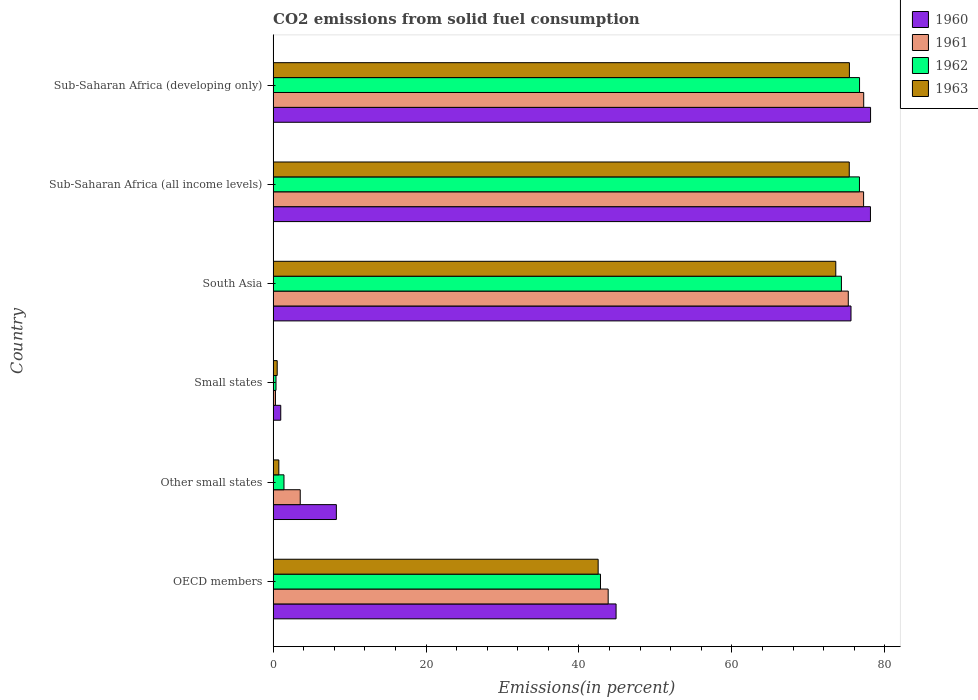How many different coloured bars are there?
Your answer should be very brief. 4. How many groups of bars are there?
Ensure brevity in your answer.  6. What is the label of the 2nd group of bars from the top?
Ensure brevity in your answer.  Sub-Saharan Africa (all income levels). In how many cases, is the number of bars for a given country not equal to the number of legend labels?
Offer a very short reply. 0. What is the total CO2 emitted in 1960 in Other small states?
Keep it short and to the point. 8.27. Across all countries, what is the maximum total CO2 emitted in 1963?
Provide a short and direct response. 75.37. Across all countries, what is the minimum total CO2 emitted in 1962?
Your answer should be compact. 0.38. In which country was the total CO2 emitted in 1962 maximum?
Your response must be concise. Sub-Saharan Africa (developing only). In which country was the total CO2 emitted in 1962 minimum?
Provide a short and direct response. Small states. What is the total total CO2 emitted in 1961 in the graph?
Make the answer very short. 277.38. What is the difference between the total CO2 emitted in 1960 in South Asia and that in Sub-Saharan Africa (all income levels)?
Offer a very short reply. -2.54. What is the difference between the total CO2 emitted in 1960 in Sub-Saharan Africa (all income levels) and the total CO2 emitted in 1961 in South Asia?
Keep it short and to the point. 2.9. What is the average total CO2 emitted in 1961 per country?
Ensure brevity in your answer.  46.23. What is the difference between the total CO2 emitted in 1961 and total CO2 emitted in 1962 in South Asia?
Ensure brevity in your answer.  0.9. What is the ratio of the total CO2 emitted in 1961 in Other small states to that in Sub-Saharan Africa (all income levels)?
Give a very brief answer. 0.05. Is the total CO2 emitted in 1963 in Small states less than that in Sub-Saharan Africa (developing only)?
Your answer should be compact. Yes. What is the difference between the highest and the second highest total CO2 emitted in 1963?
Your answer should be very brief. 0.02. What is the difference between the highest and the lowest total CO2 emitted in 1961?
Give a very brief answer. 76.94. In how many countries, is the total CO2 emitted in 1961 greater than the average total CO2 emitted in 1961 taken over all countries?
Your response must be concise. 3. Is the sum of the total CO2 emitted in 1963 in Other small states and Small states greater than the maximum total CO2 emitted in 1960 across all countries?
Your response must be concise. No. Is it the case that in every country, the sum of the total CO2 emitted in 1963 and total CO2 emitted in 1961 is greater than the sum of total CO2 emitted in 1960 and total CO2 emitted in 1962?
Ensure brevity in your answer.  No. Is it the case that in every country, the sum of the total CO2 emitted in 1960 and total CO2 emitted in 1963 is greater than the total CO2 emitted in 1961?
Keep it short and to the point. Yes. How many bars are there?
Give a very brief answer. 24. How many countries are there in the graph?
Your response must be concise. 6. What is the difference between two consecutive major ticks on the X-axis?
Offer a terse response. 20. Are the values on the major ticks of X-axis written in scientific E-notation?
Your answer should be very brief. No. Does the graph contain any zero values?
Your answer should be very brief. No. Where does the legend appear in the graph?
Provide a succinct answer. Top right. How many legend labels are there?
Your answer should be very brief. 4. How are the legend labels stacked?
Provide a short and direct response. Vertical. What is the title of the graph?
Offer a terse response. CO2 emissions from solid fuel consumption. What is the label or title of the X-axis?
Offer a very short reply. Emissions(in percent). What is the Emissions(in percent) in 1960 in OECD members?
Provide a short and direct response. 44.86. What is the Emissions(in percent) in 1961 in OECD members?
Your answer should be compact. 43.82. What is the Emissions(in percent) of 1962 in OECD members?
Provide a succinct answer. 42.82. What is the Emissions(in percent) of 1963 in OECD members?
Give a very brief answer. 42.51. What is the Emissions(in percent) in 1960 in Other small states?
Your response must be concise. 8.27. What is the Emissions(in percent) in 1961 in Other small states?
Make the answer very short. 3.55. What is the Emissions(in percent) in 1962 in Other small states?
Ensure brevity in your answer.  1.42. What is the Emissions(in percent) in 1963 in Other small states?
Provide a succinct answer. 0.75. What is the Emissions(in percent) of 1960 in Small states?
Give a very brief answer. 1. What is the Emissions(in percent) of 1961 in Small states?
Provide a succinct answer. 0.31. What is the Emissions(in percent) in 1962 in Small states?
Give a very brief answer. 0.38. What is the Emissions(in percent) in 1963 in Small states?
Give a very brief answer. 0.53. What is the Emissions(in percent) of 1960 in South Asia?
Give a very brief answer. 75.58. What is the Emissions(in percent) in 1961 in South Asia?
Your response must be concise. 75.23. What is the Emissions(in percent) in 1962 in South Asia?
Offer a terse response. 74.33. What is the Emissions(in percent) in 1963 in South Asia?
Keep it short and to the point. 73.59. What is the Emissions(in percent) of 1960 in Sub-Saharan Africa (all income levels)?
Your answer should be compact. 78.13. What is the Emissions(in percent) in 1961 in Sub-Saharan Africa (all income levels)?
Offer a terse response. 77.23. What is the Emissions(in percent) of 1962 in Sub-Saharan Africa (all income levels)?
Provide a short and direct response. 76.69. What is the Emissions(in percent) in 1963 in Sub-Saharan Africa (all income levels)?
Ensure brevity in your answer.  75.35. What is the Emissions(in percent) of 1960 in Sub-Saharan Africa (developing only)?
Your answer should be compact. 78.14. What is the Emissions(in percent) of 1961 in Sub-Saharan Africa (developing only)?
Your response must be concise. 77.24. What is the Emissions(in percent) of 1962 in Sub-Saharan Africa (developing only)?
Your response must be concise. 76.7. What is the Emissions(in percent) in 1963 in Sub-Saharan Africa (developing only)?
Provide a short and direct response. 75.37. Across all countries, what is the maximum Emissions(in percent) in 1960?
Offer a terse response. 78.14. Across all countries, what is the maximum Emissions(in percent) of 1961?
Make the answer very short. 77.24. Across all countries, what is the maximum Emissions(in percent) of 1962?
Keep it short and to the point. 76.7. Across all countries, what is the maximum Emissions(in percent) in 1963?
Give a very brief answer. 75.37. Across all countries, what is the minimum Emissions(in percent) in 1960?
Your answer should be compact. 1. Across all countries, what is the minimum Emissions(in percent) in 1961?
Offer a terse response. 0.31. Across all countries, what is the minimum Emissions(in percent) of 1962?
Offer a terse response. 0.38. Across all countries, what is the minimum Emissions(in percent) in 1963?
Provide a succinct answer. 0.53. What is the total Emissions(in percent) in 1960 in the graph?
Make the answer very short. 285.97. What is the total Emissions(in percent) in 1961 in the graph?
Offer a very short reply. 277.38. What is the total Emissions(in percent) of 1962 in the graph?
Give a very brief answer. 272.33. What is the total Emissions(in percent) in 1963 in the graph?
Offer a very short reply. 268.11. What is the difference between the Emissions(in percent) in 1960 in OECD members and that in Other small states?
Ensure brevity in your answer.  36.58. What is the difference between the Emissions(in percent) of 1961 in OECD members and that in Other small states?
Your answer should be compact. 40.28. What is the difference between the Emissions(in percent) in 1962 in OECD members and that in Other small states?
Your answer should be very brief. 41.4. What is the difference between the Emissions(in percent) of 1963 in OECD members and that in Other small states?
Make the answer very short. 41.77. What is the difference between the Emissions(in percent) in 1960 in OECD members and that in Small states?
Your answer should be very brief. 43.86. What is the difference between the Emissions(in percent) in 1961 in OECD members and that in Small states?
Offer a terse response. 43.52. What is the difference between the Emissions(in percent) in 1962 in OECD members and that in Small states?
Offer a very short reply. 42.44. What is the difference between the Emissions(in percent) in 1963 in OECD members and that in Small states?
Offer a very short reply. 41.98. What is the difference between the Emissions(in percent) in 1960 in OECD members and that in South Asia?
Offer a very short reply. -30.73. What is the difference between the Emissions(in percent) of 1961 in OECD members and that in South Asia?
Offer a very short reply. -31.41. What is the difference between the Emissions(in percent) in 1962 in OECD members and that in South Asia?
Keep it short and to the point. -31.51. What is the difference between the Emissions(in percent) of 1963 in OECD members and that in South Asia?
Offer a terse response. -31.08. What is the difference between the Emissions(in percent) in 1960 in OECD members and that in Sub-Saharan Africa (all income levels)?
Ensure brevity in your answer.  -33.27. What is the difference between the Emissions(in percent) of 1961 in OECD members and that in Sub-Saharan Africa (all income levels)?
Your response must be concise. -33.41. What is the difference between the Emissions(in percent) of 1962 in OECD members and that in Sub-Saharan Africa (all income levels)?
Offer a very short reply. -33.87. What is the difference between the Emissions(in percent) in 1963 in OECD members and that in Sub-Saharan Africa (all income levels)?
Offer a terse response. -32.84. What is the difference between the Emissions(in percent) in 1960 in OECD members and that in Sub-Saharan Africa (developing only)?
Ensure brevity in your answer.  -33.28. What is the difference between the Emissions(in percent) in 1961 in OECD members and that in Sub-Saharan Africa (developing only)?
Your answer should be compact. -33.42. What is the difference between the Emissions(in percent) in 1962 in OECD members and that in Sub-Saharan Africa (developing only)?
Ensure brevity in your answer.  -33.89. What is the difference between the Emissions(in percent) in 1963 in OECD members and that in Sub-Saharan Africa (developing only)?
Your answer should be compact. -32.86. What is the difference between the Emissions(in percent) in 1960 in Other small states and that in Small states?
Keep it short and to the point. 7.27. What is the difference between the Emissions(in percent) of 1961 in Other small states and that in Small states?
Your answer should be very brief. 3.24. What is the difference between the Emissions(in percent) in 1962 in Other small states and that in Small states?
Provide a succinct answer. 1.04. What is the difference between the Emissions(in percent) in 1963 in Other small states and that in Small states?
Your response must be concise. 0.21. What is the difference between the Emissions(in percent) in 1960 in Other small states and that in South Asia?
Your response must be concise. -67.31. What is the difference between the Emissions(in percent) of 1961 in Other small states and that in South Asia?
Your answer should be very brief. -71.68. What is the difference between the Emissions(in percent) in 1962 in Other small states and that in South Asia?
Offer a terse response. -72.91. What is the difference between the Emissions(in percent) in 1963 in Other small states and that in South Asia?
Make the answer very short. -72.85. What is the difference between the Emissions(in percent) of 1960 in Other small states and that in Sub-Saharan Africa (all income levels)?
Your answer should be very brief. -69.86. What is the difference between the Emissions(in percent) of 1961 in Other small states and that in Sub-Saharan Africa (all income levels)?
Your answer should be compact. -73.68. What is the difference between the Emissions(in percent) of 1962 in Other small states and that in Sub-Saharan Africa (all income levels)?
Your response must be concise. -75.27. What is the difference between the Emissions(in percent) of 1963 in Other small states and that in Sub-Saharan Africa (all income levels)?
Offer a very short reply. -74.61. What is the difference between the Emissions(in percent) in 1960 in Other small states and that in Sub-Saharan Africa (developing only)?
Make the answer very short. -69.87. What is the difference between the Emissions(in percent) in 1961 in Other small states and that in Sub-Saharan Africa (developing only)?
Your answer should be compact. -73.7. What is the difference between the Emissions(in percent) of 1962 in Other small states and that in Sub-Saharan Africa (developing only)?
Keep it short and to the point. -75.28. What is the difference between the Emissions(in percent) of 1963 in Other small states and that in Sub-Saharan Africa (developing only)?
Your answer should be compact. -74.63. What is the difference between the Emissions(in percent) in 1960 in Small states and that in South Asia?
Make the answer very short. -74.58. What is the difference between the Emissions(in percent) in 1961 in Small states and that in South Asia?
Offer a terse response. -74.92. What is the difference between the Emissions(in percent) of 1962 in Small states and that in South Asia?
Provide a short and direct response. -73.95. What is the difference between the Emissions(in percent) of 1963 in Small states and that in South Asia?
Make the answer very short. -73.06. What is the difference between the Emissions(in percent) of 1960 in Small states and that in Sub-Saharan Africa (all income levels)?
Provide a short and direct response. -77.13. What is the difference between the Emissions(in percent) of 1961 in Small states and that in Sub-Saharan Africa (all income levels)?
Offer a terse response. -76.92. What is the difference between the Emissions(in percent) in 1962 in Small states and that in Sub-Saharan Africa (all income levels)?
Offer a very short reply. -76.31. What is the difference between the Emissions(in percent) in 1963 in Small states and that in Sub-Saharan Africa (all income levels)?
Your answer should be very brief. -74.82. What is the difference between the Emissions(in percent) of 1960 in Small states and that in Sub-Saharan Africa (developing only)?
Provide a succinct answer. -77.14. What is the difference between the Emissions(in percent) in 1961 in Small states and that in Sub-Saharan Africa (developing only)?
Your response must be concise. -76.94. What is the difference between the Emissions(in percent) of 1962 in Small states and that in Sub-Saharan Africa (developing only)?
Ensure brevity in your answer.  -76.32. What is the difference between the Emissions(in percent) in 1963 in Small states and that in Sub-Saharan Africa (developing only)?
Provide a short and direct response. -74.84. What is the difference between the Emissions(in percent) of 1960 in South Asia and that in Sub-Saharan Africa (all income levels)?
Your answer should be compact. -2.54. What is the difference between the Emissions(in percent) in 1961 in South Asia and that in Sub-Saharan Africa (all income levels)?
Your response must be concise. -2. What is the difference between the Emissions(in percent) of 1962 in South Asia and that in Sub-Saharan Africa (all income levels)?
Your response must be concise. -2.36. What is the difference between the Emissions(in percent) of 1963 in South Asia and that in Sub-Saharan Africa (all income levels)?
Provide a short and direct response. -1.76. What is the difference between the Emissions(in percent) in 1960 in South Asia and that in Sub-Saharan Africa (developing only)?
Ensure brevity in your answer.  -2.56. What is the difference between the Emissions(in percent) in 1961 in South Asia and that in Sub-Saharan Africa (developing only)?
Make the answer very short. -2.02. What is the difference between the Emissions(in percent) in 1962 in South Asia and that in Sub-Saharan Africa (developing only)?
Your answer should be compact. -2.37. What is the difference between the Emissions(in percent) of 1963 in South Asia and that in Sub-Saharan Africa (developing only)?
Provide a succinct answer. -1.78. What is the difference between the Emissions(in percent) in 1960 in Sub-Saharan Africa (all income levels) and that in Sub-Saharan Africa (developing only)?
Keep it short and to the point. -0.01. What is the difference between the Emissions(in percent) of 1961 in Sub-Saharan Africa (all income levels) and that in Sub-Saharan Africa (developing only)?
Provide a succinct answer. -0.01. What is the difference between the Emissions(in percent) of 1962 in Sub-Saharan Africa (all income levels) and that in Sub-Saharan Africa (developing only)?
Keep it short and to the point. -0.01. What is the difference between the Emissions(in percent) in 1963 in Sub-Saharan Africa (all income levels) and that in Sub-Saharan Africa (developing only)?
Provide a short and direct response. -0.02. What is the difference between the Emissions(in percent) in 1960 in OECD members and the Emissions(in percent) in 1961 in Other small states?
Keep it short and to the point. 41.31. What is the difference between the Emissions(in percent) in 1960 in OECD members and the Emissions(in percent) in 1962 in Other small states?
Your answer should be very brief. 43.44. What is the difference between the Emissions(in percent) of 1960 in OECD members and the Emissions(in percent) of 1963 in Other small states?
Your answer should be compact. 44.11. What is the difference between the Emissions(in percent) of 1961 in OECD members and the Emissions(in percent) of 1962 in Other small states?
Your answer should be compact. 42.4. What is the difference between the Emissions(in percent) in 1961 in OECD members and the Emissions(in percent) in 1963 in Other small states?
Your answer should be compact. 43.08. What is the difference between the Emissions(in percent) of 1962 in OECD members and the Emissions(in percent) of 1963 in Other small states?
Give a very brief answer. 42.07. What is the difference between the Emissions(in percent) in 1960 in OECD members and the Emissions(in percent) in 1961 in Small states?
Provide a short and direct response. 44.55. What is the difference between the Emissions(in percent) in 1960 in OECD members and the Emissions(in percent) in 1962 in Small states?
Offer a very short reply. 44.48. What is the difference between the Emissions(in percent) in 1960 in OECD members and the Emissions(in percent) in 1963 in Small states?
Give a very brief answer. 44.32. What is the difference between the Emissions(in percent) in 1961 in OECD members and the Emissions(in percent) in 1962 in Small states?
Ensure brevity in your answer.  43.45. What is the difference between the Emissions(in percent) of 1961 in OECD members and the Emissions(in percent) of 1963 in Small states?
Give a very brief answer. 43.29. What is the difference between the Emissions(in percent) of 1962 in OECD members and the Emissions(in percent) of 1963 in Small states?
Offer a terse response. 42.28. What is the difference between the Emissions(in percent) of 1960 in OECD members and the Emissions(in percent) of 1961 in South Asia?
Offer a very short reply. -30.37. What is the difference between the Emissions(in percent) of 1960 in OECD members and the Emissions(in percent) of 1962 in South Asia?
Provide a succinct answer. -29.47. What is the difference between the Emissions(in percent) in 1960 in OECD members and the Emissions(in percent) in 1963 in South Asia?
Your answer should be very brief. -28.74. What is the difference between the Emissions(in percent) of 1961 in OECD members and the Emissions(in percent) of 1962 in South Asia?
Provide a short and direct response. -30.51. What is the difference between the Emissions(in percent) in 1961 in OECD members and the Emissions(in percent) in 1963 in South Asia?
Keep it short and to the point. -29.77. What is the difference between the Emissions(in percent) in 1962 in OECD members and the Emissions(in percent) in 1963 in South Asia?
Keep it short and to the point. -30.78. What is the difference between the Emissions(in percent) in 1960 in OECD members and the Emissions(in percent) in 1961 in Sub-Saharan Africa (all income levels)?
Your response must be concise. -32.37. What is the difference between the Emissions(in percent) of 1960 in OECD members and the Emissions(in percent) of 1962 in Sub-Saharan Africa (all income levels)?
Keep it short and to the point. -31.83. What is the difference between the Emissions(in percent) of 1960 in OECD members and the Emissions(in percent) of 1963 in Sub-Saharan Africa (all income levels)?
Offer a terse response. -30.5. What is the difference between the Emissions(in percent) of 1961 in OECD members and the Emissions(in percent) of 1962 in Sub-Saharan Africa (all income levels)?
Provide a succinct answer. -32.87. What is the difference between the Emissions(in percent) of 1961 in OECD members and the Emissions(in percent) of 1963 in Sub-Saharan Africa (all income levels)?
Make the answer very short. -31.53. What is the difference between the Emissions(in percent) in 1962 in OECD members and the Emissions(in percent) in 1963 in Sub-Saharan Africa (all income levels)?
Provide a succinct answer. -32.54. What is the difference between the Emissions(in percent) in 1960 in OECD members and the Emissions(in percent) in 1961 in Sub-Saharan Africa (developing only)?
Offer a terse response. -32.39. What is the difference between the Emissions(in percent) of 1960 in OECD members and the Emissions(in percent) of 1962 in Sub-Saharan Africa (developing only)?
Ensure brevity in your answer.  -31.85. What is the difference between the Emissions(in percent) in 1960 in OECD members and the Emissions(in percent) in 1963 in Sub-Saharan Africa (developing only)?
Provide a short and direct response. -30.52. What is the difference between the Emissions(in percent) in 1961 in OECD members and the Emissions(in percent) in 1962 in Sub-Saharan Africa (developing only)?
Keep it short and to the point. -32.88. What is the difference between the Emissions(in percent) in 1961 in OECD members and the Emissions(in percent) in 1963 in Sub-Saharan Africa (developing only)?
Your answer should be compact. -31.55. What is the difference between the Emissions(in percent) of 1962 in OECD members and the Emissions(in percent) of 1963 in Sub-Saharan Africa (developing only)?
Keep it short and to the point. -32.56. What is the difference between the Emissions(in percent) of 1960 in Other small states and the Emissions(in percent) of 1961 in Small states?
Make the answer very short. 7.96. What is the difference between the Emissions(in percent) in 1960 in Other small states and the Emissions(in percent) in 1962 in Small states?
Make the answer very short. 7.89. What is the difference between the Emissions(in percent) in 1960 in Other small states and the Emissions(in percent) in 1963 in Small states?
Your answer should be compact. 7.74. What is the difference between the Emissions(in percent) of 1961 in Other small states and the Emissions(in percent) of 1962 in Small states?
Your response must be concise. 3.17. What is the difference between the Emissions(in percent) in 1961 in Other small states and the Emissions(in percent) in 1963 in Small states?
Provide a short and direct response. 3.01. What is the difference between the Emissions(in percent) of 1962 in Other small states and the Emissions(in percent) of 1963 in Small states?
Offer a very short reply. 0.88. What is the difference between the Emissions(in percent) in 1960 in Other small states and the Emissions(in percent) in 1961 in South Asia?
Offer a very short reply. -66.96. What is the difference between the Emissions(in percent) in 1960 in Other small states and the Emissions(in percent) in 1962 in South Asia?
Offer a very short reply. -66.06. What is the difference between the Emissions(in percent) of 1960 in Other small states and the Emissions(in percent) of 1963 in South Asia?
Your response must be concise. -65.32. What is the difference between the Emissions(in percent) in 1961 in Other small states and the Emissions(in percent) in 1962 in South Asia?
Offer a terse response. -70.78. What is the difference between the Emissions(in percent) of 1961 in Other small states and the Emissions(in percent) of 1963 in South Asia?
Provide a short and direct response. -70.05. What is the difference between the Emissions(in percent) of 1962 in Other small states and the Emissions(in percent) of 1963 in South Asia?
Offer a terse response. -72.17. What is the difference between the Emissions(in percent) of 1960 in Other small states and the Emissions(in percent) of 1961 in Sub-Saharan Africa (all income levels)?
Offer a very short reply. -68.96. What is the difference between the Emissions(in percent) in 1960 in Other small states and the Emissions(in percent) in 1962 in Sub-Saharan Africa (all income levels)?
Offer a terse response. -68.42. What is the difference between the Emissions(in percent) of 1960 in Other small states and the Emissions(in percent) of 1963 in Sub-Saharan Africa (all income levels)?
Provide a short and direct response. -67.08. What is the difference between the Emissions(in percent) in 1961 in Other small states and the Emissions(in percent) in 1962 in Sub-Saharan Africa (all income levels)?
Keep it short and to the point. -73.14. What is the difference between the Emissions(in percent) in 1961 in Other small states and the Emissions(in percent) in 1963 in Sub-Saharan Africa (all income levels)?
Provide a succinct answer. -71.81. What is the difference between the Emissions(in percent) of 1962 in Other small states and the Emissions(in percent) of 1963 in Sub-Saharan Africa (all income levels)?
Your answer should be very brief. -73.94. What is the difference between the Emissions(in percent) of 1960 in Other small states and the Emissions(in percent) of 1961 in Sub-Saharan Africa (developing only)?
Provide a short and direct response. -68.97. What is the difference between the Emissions(in percent) in 1960 in Other small states and the Emissions(in percent) in 1962 in Sub-Saharan Africa (developing only)?
Ensure brevity in your answer.  -68.43. What is the difference between the Emissions(in percent) in 1960 in Other small states and the Emissions(in percent) in 1963 in Sub-Saharan Africa (developing only)?
Provide a short and direct response. -67.1. What is the difference between the Emissions(in percent) in 1961 in Other small states and the Emissions(in percent) in 1962 in Sub-Saharan Africa (developing only)?
Your response must be concise. -73.15. What is the difference between the Emissions(in percent) of 1961 in Other small states and the Emissions(in percent) of 1963 in Sub-Saharan Africa (developing only)?
Provide a short and direct response. -71.83. What is the difference between the Emissions(in percent) of 1962 in Other small states and the Emissions(in percent) of 1963 in Sub-Saharan Africa (developing only)?
Your answer should be compact. -73.95. What is the difference between the Emissions(in percent) of 1960 in Small states and the Emissions(in percent) of 1961 in South Asia?
Provide a short and direct response. -74.23. What is the difference between the Emissions(in percent) of 1960 in Small states and the Emissions(in percent) of 1962 in South Asia?
Make the answer very short. -73.33. What is the difference between the Emissions(in percent) in 1960 in Small states and the Emissions(in percent) in 1963 in South Asia?
Make the answer very short. -72.59. What is the difference between the Emissions(in percent) of 1961 in Small states and the Emissions(in percent) of 1962 in South Asia?
Provide a short and direct response. -74.02. What is the difference between the Emissions(in percent) of 1961 in Small states and the Emissions(in percent) of 1963 in South Asia?
Provide a short and direct response. -73.29. What is the difference between the Emissions(in percent) in 1962 in Small states and the Emissions(in percent) in 1963 in South Asia?
Your answer should be compact. -73.22. What is the difference between the Emissions(in percent) in 1960 in Small states and the Emissions(in percent) in 1961 in Sub-Saharan Africa (all income levels)?
Your response must be concise. -76.23. What is the difference between the Emissions(in percent) in 1960 in Small states and the Emissions(in percent) in 1962 in Sub-Saharan Africa (all income levels)?
Provide a succinct answer. -75.69. What is the difference between the Emissions(in percent) of 1960 in Small states and the Emissions(in percent) of 1963 in Sub-Saharan Africa (all income levels)?
Make the answer very short. -74.36. What is the difference between the Emissions(in percent) of 1961 in Small states and the Emissions(in percent) of 1962 in Sub-Saharan Africa (all income levels)?
Your answer should be compact. -76.38. What is the difference between the Emissions(in percent) of 1961 in Small states and the Emissions(in percent) of 1963 in Sub-Saharan Africa (all income levels)?
Your response must be concise. -75.05. What is the difference between the Emissions(in percent) in 1962 in Small states and the Emissions(in percent) in 1963 in Sub-Saharan Africa (all income levels)?
Your response must be concise. -74.98. What is the difference between the Emissions(in percent) in 1960 in Small states and the Emissions(in percent) in 1961 in Sub-Saharan Africa (developing only)?
Offer a very short reply. -76.25. What is the difference between the Emissions(in percent) in 1960 in Small states and the Emissions(in percent) in 1962 in Sub-Saharan Africa (developing only)?
Keep it short and to the point. -75.7. What is the difference between the Emissions(in percent) of 1960 in Small states and the Emissions(in percent) of 1963 in Sub-Saharan Africa (developing only)?
Make the answer very short. -74.38. What is the difference between the Emissions(in percent) of 1961 in Small states and the Emissions(in percent) of 1962 in Sub-Saharan Africa (developing only)?
Your answer should be compact. -76.4. What is the difference between the Emissions(in percent) in 1961 in Small states and the Emissions(in percent) in 1963 in Sub-Saharan Africa (developing only)?
Ensure brevity in your answer.  -75.07. What is the difference between the Emissions(in percent) of 1962 in Small states and the Emissions(in percent) of 1963 in Sub-Saharan Africa (developing only)?
Your response must be concise. -75. What is the difference between the Emissions(in percent) in 1960 in South Asia and the Emissions(in percent) in 1961 in Sub-Saharan Africa (all income levels)?
Your answer should be compact. -1.65. What is the difference between the Emissions(in percent) in 1960 in South Asia and the Emissions(in percent) in 1962 in Sub-Saharan Africa (all income levels)?
Ensure brevity in your answer.  -1.1. What is the difference between the Emissions(in percent) in 1960 in South Asia and the Emissions(in percent) in 1963 in Sub-Saharan Africa (all income levels)?
Provide a succinct answer. 0.23. What is the difference between the Emissions(in percent) of 1961 in South Asia and the Emissions(in percent) of 1962 in Sub-Saharan Africa (all income levels)?
Your answer should be compact. -1.46. What is the difference between the Emissions(in percent) of 1961 in South Asia and the Emissions(in percent) of 1963 in Sub-Saharan Africa (all income levels)?
Make the answer very short. -0.13. What is the difference between the Emissions(in percent) in 1962 in South Asia and the Emissions(in percent) in 1963 in Sub-Saharan Africa (all income levels)?
Make the answer very short. -1.03. What is the difference between the Emissions(in percent) in 1960 in South Asia and the Emissions(in percent) in 1961 in Sub-Saharan Africa (developing only)?
Provide a short and direct response. -1.66. What is the difference between the Emissions(in percent) in 1960 in South Asia and the Emissions(in percent) in 1962 in Sub-Saharan Africa (developing only)?
Keep it short and to the point. -1.12. What is the difference between the Emissions(in percent) of 1960 in South Asia and the Emissions(in percent) of 1963 in Sub-Saharan Africa (developing only)?
Your answer should be very brief. 0.21. What is the difference between the Emissions(in percent) in 1961 in South Asia and the Emissions(in percent) in 1962 in Sub-Saharan Africa (developing only)?
Offer a very short reply. -1.47. What is the difference between the Emissions(in percent) of 1961 in South Asia and the Emissions(in percent) of 1963 in Sub-Saharan Africa (developing only)?
Your answer should be compact. -0.15. What is the difference between the Emissions(in percent) in 1962 in South Asia and the Emissions(in percent) in 1963 in Sub-Saharan Africa (developing only)?
Provide a succinct answer. -1.04. What is the difference between the Emissions(in percent) of 1960 in Sub-Saharan Africa (all income levels) and the Emissions(in percent) of 1961 in Sub-Saharan Africa (developing only)?
Make the answer very short. 0.88. What is the difference between the Emissions(in percent) in 1960 in Sub-Saharan Africa (all income levels) and the Emissions(in percent) in 1962 in Sub-Saharan Africa (developing only)?
Your answer should be compact. 1.42. What is the difference between the Emissions(in percent) in 1960 in Sub-Saharan Africa (all income levels) and the Emissions(in percent) in 1963 in Sub-Saharan Africa (developing only)?
Make the answer very short. 2.75. What is the difference between the Emissions(in percent) of 1961 in Sub-Saharan Africa (all income levels) and the Emissions(in percent) of 1962 in Sub-Saharan Africa (developing only)?
Your answer should be compact. 0.53. What is the difference between the Emissions(in percent) of 1961 in Sub-Saharan Africa (all income levels) and the Emissions(in percent) of 1963 in Sub-Saharan Africa (developing only)?
Offer a very short reply. 1.86. What is the difference between the Emissions(in percent) in 1962 in Sub-Saharan Africa (all income levels) and the Emissions(in percent) in 1963 in Sub-Saharan Africa (developing only)?
Provide a short and direct response. 1.31. What is the average Emissions(in percent) in 1960 per country?
Ensure brevity in your answer.  47.66. What is the average Emissions(in percent) of 1961 per country?
Provide a succinct answer. 46.23. What is the average Emissions(in percent) in 1962 per country?
Offer a very short reply. 45.39. What is the average Emissions(in percent) in 1963 per country?
Keep it short and to the point. 44.69. What is the difference between the Emissions(in percent) in 1960 and Emissions(in percent) in 1962 in OECD members?
Provide a succinct answer. 2.04. What is the difference between the Emissions(in percent) of 1960 and Emissions(in percent) of 1963 in OECD members?
Give a very brief answer. 2.34. What is the difference between the Emissions(in percent) of 1961 and Emissions(in percent) of 1962 in OECD members?
Give a very brief answer. 1.01. What is the difference between the Emissions(in percent) in 1961 and Emissions(in percent) in 1963 in OECD members?
Offer a terse response. 1.31. What is the difference between the Emissions(in percent) of 1962 and Emissions(in percent) of 1963 in OECD members?
Your response must be concise. 0.3. What is the difference between the Emissions(in percent) of 1960 and Emissions(in percent) of 1961 in Other small states?
Provide a short and direct response. 4.72. What is the difference between the Emissions(in percent) in 1960 and Emissions(in percent) in 1962 in Other small states?
Your answer should be compact. 6.85. What is the difference between the Emissions(in percent) of 1960 and Emissions(in percent) of 1963 in Other small states?
Provide a succinct answer. 7.52. What is the difference between the Emissions(in percent) in 1961 and Emissions(in percent) in 1962 in Other small states?
Offer a terse response. 2.13. What is the difference between the Emissions(in percent) in 1961 and Emissions(in percent) in 1963 in Other small states?
Make the answer very short. 2.8. What is the difference between the Emissions(in percent) in 1962 and Emissions(in percent) in 1963 in Other small states?
Ensure brevity in your answer.  0.67. What is the difference between the Emissions(in percent) of 1960 and Emissions(in percent) of 1961 in Small states?
Your answer should be compact. 0.69. What is the difference between the Emissions(in percent) in 1960 and Emissions(in percent) in 1962 in Small states?
Offer a very short reply. 0.62. What is the difference between the Emissions(in percent) of 1960 and Emissions(in percent) of 1963 in Small states?
Provide a succinct answer. 0.46. What is the difference between the Emissions(in percent) in 1961 and Emissions(in percent) in 1962 in Small states?
Offer a very short reply. -0.07. What is the difference between the Emissions(in percent) of 1961 and Emissions(in percent) of 1963 in Small states?
Offer a terse response. -0.23. What is the difference between the Emissions(in percent) of 1962 and Emissions(in percent) of 1963 in Small states?
Your answer should be compact. -0.16. What is the difference between the Emissions(in percent) in 1960 and Emissions(in percent) in 1961 in South Asia?
Provide a succinct answer. 0.36. What is the difference between the Emissions(in percent) in 1960 and Emissions(in percent) in 1962 in South Asia?
Offer a terse response. 1.25. What is the difference between the Emissions(in percent) in 1960 and Emissions(in percent) in 1963 in South Asia?
Your answer should be compact. 1.99. What is the difference between the Emissions(in percent) in 1961 and Emissions(in percent) in 1962 in South Asia?
Give a very brief answer. 0.9. What is the difference between the Emissions(in percent) in 1961 and Emissions(in percent) in 1963 in South Asia?
Ensure brevity in your answer.  1.63. What is the difference between the Emissions(in percent) in 1962 and Emissions(in percent) in 1963 in South Asia?
Your answer should be very brief. 0.74. What is the difference between the Emissions(in percent) of 1960 and Emissions(in percent) of 1961 in Sub-Saharan Africa (all income levels)?
Ensure brevity in your answer.  0.9. What is the difference between the Emissions(in percent) of 1960 and Emissions(in percent) of 1962 in Sub-Saharan Africa (all income levels)?
Your answer should be compact. 1.44. What is the difference between the Emissions(in percent) in 1960 and Emissions(in percent) in 1963 in Sub-Saharan Africa (all income levels)?
Provide a succinct answer. 2.77. What is the difference between the Emissions(in percent) of 1961 and Emissions(in percent) of 1962 in Sub-Saharan Africa (all income levels)?
Your response must be concise. 0.54. What is the difference between the Emissions(in percent) in 1961 and Emissions(in percent) in 1963 in Sub-Saharan Africa (all income levels)?
Give a very brief answer. 1.88. What is the difference between the Emissions(in percent) in 1962 and Emissions(in percent) in 1963 in Sub-Saharan Africa (all income levels)?
Offer a very short reply. 1.33. What is the difference between the Emissions(in percent) in 1960 and Emissions(in percent) in 1961 in Sub-Saharan Africa (developing only)?
Keep it short and to the point. 0.9. What is the difference between the Emissions(in percent) of 1960 and Emissions(in percent) of 1962 in Sub-Saharan Africa (developing only)?
Your response must be concise. 1.44. What is the difference between the Emissions(in percent) of 1960 and Emissions(in percent) of 1963 in Sub-Saharan Africa (developing only)?
Give a very brief answer. 2.77. What is the difference between the Emissions(in percent) of 1961 and Emissions(in percent) of 1962 in Sub-Saharan Africa (developing only)?
Your response must be concise. 0.54. What is the difference between the Emissions(in percent) in 1961 and Emissions(in percent) in 1963 in Sub-Saharan Africa (developing only)?
Give a very brief answer. 1.87. What is the difference between the Emissions(in percent) in 1962 and Emissions(in percent) in 1963 in Sub-Saharan Africa (developing only)?
Provide a succinct answer. 1.33. What is the ratio of the Emissions(in percent) of 1960 in OECD members to that in Other small states?
Give a very brief answer. 5.42. What is the ratio of the Emissions(in percent) of 1961 in OECD members to that in Other small states?
Provide a short and direct response. 12.36. What is the ratio of the Emissions(in percent) in 1962 in OECD members to that in Other small states?
Your answer should be compact. 30.19. What is the ratio of the Emissions(in percent) of 1963 in OECD members to that in Other small states?
Offer a terse response. 56.97. What is the ratio of the Emissions(in percent) in 1960 in OECD members to that in Small states?
Your response must be concise. 44.93. What is the ratio of the Emissions(in percent) in 1961 in OECD members to that in Small states?
Ensure brevity in your answer.  143.3. What is the ratio of the Emissions(in percent) of 1962 in OECD members to that in Small states?
Make the answer very short. 113.76. What is the ratio of the Emissions(in percent) of 1963 in OECD members to that in Small states?
Your answer should be compact. 79.67. What is the ratio of the Emissions(in percent) in 1960 in OECD members to that in South Asia?
Provide a succinct answer. 0.59. What is the ratio of the Emissions(in percent) in 1961 in OECD members to that in South Asia?
Offer a terse response. 0.58. What is the ratio of the Emissions(in percent) in 1962 in OECD members to that in South Asia?
Provide a short and direct response. 0.58. What is the ratio of the Emissions(in percent) in 1963 in OECD members to that in South Asia?
Make the answer very short. 0.58. What is the ratio of the Emissions(in percent) in 1960 in OECD members to that in Sub-Saharan Africa (all income levels)?
Provide a succinct answer. 0.57. What is the ratio of the Emissions(in percent) in 1961 in OECD members to that in Sub-Saharan Africa (all income levels)?
Offer a very short reply. 0.57. What is the ratio of the Emissions(in percent) of 1962 in OECD members to that in Sub-Saharan Africa (all income levels)?
Your answer should be compact. 0.56. What is the ratio of the Emissions(in percent) in 1963 in OECD members to that in Sub-Saharan Africa (all income levels)?
Your response must be concise. 0.56. What is the ratio of the Emissions(in percent) of 1960 in OECD members to that in Sub-Saharan Africa (developing only)?
Your answer should be very brief. 0.57. What is the ratio of the Emissions(in percent) of 1961 in OECD members to that in Sub-Saharan Africa (developing only)?
Your answer should be compact. 0.57. What is the ratio of the Emissions(in percent) in 1962 in OECD members to that in Sub-Saharan Africa (developing only)?
Offer a very short reply. 0.56. What is the ratio of the Emissions(in percent) of 1963 in OECD members to that in Sub-Saharan Africa (developing only)?
Your answer should be very brief. 0.56. What is the ratio of the Emissions(in percent) in 1960 in Other small states to that in Small states?
Your answer should be compact. 8.28. What is the ratio of the Emissions(in percent) in 1961 in Other small states to that in Small states?
Offer a very short reply. 11.6. What is the ratio of the Emissions(in percent) in 1962 in Other small states to that in Small states?
Offer a terse response. 3.77. What is the ratio of the Emissions(in percent) in 1963 in Other small states to that in Small states?
Give a very brief answer. 1.4. What is the ratio of the Emissions(in percent) of 1960 in Other small states to that in South Asia?
Offer a terse response. 0.11. What is the ratio of the Emissions(in percent) in 1961 in Other small states to that in South Asia?
Give a very brief answer. 0.05. What is the ratio of the Emissions(in percent) in 1962 in Other small states to that in South Asia?
Make the answer very short. 0.02. What is the ratio of the Emissions(in percent) in 1963 in Other small states to that in South Asia?
Your answer should be compact. 0.01. What is the ratio of the Emissions(in percent) of 1960 in Other small states to that in Sub-Saharan Africa (all income levels)?
Offer a terse response. 0.11. What is the ratio of the Emissions(in percent) of 1961 in Other small states to that in Sub-Saharan Africa (all income levels)?
Offer a very short reply. 0.05. What is the ratio of the Emissions(in percent) of 1962 in Other small states to that in Sub-Saharan Africa (all income levels)?
Keep it short and to the point. 0.02. What is the ratio of the Emissions(in percent) of 1963 in Other small states to that in Sub-Saharan Africa (all income levels)?
Give a very brief answer. 0.01. What is the ratio of the Emissions(in percent) of 1960 in Other small states to that in Sub-Saharan Africa (developing only)?
Offer a very short reply. 0.11. What is the ratio of the Emissions(in percent) of 1961 in Other small states to that in Sub-Saharan Africa (developing only)?
Offer a very short reply. 0.05. What is the ratio of the Emissions(in percent) of 1962 in Other small states to that in Sub-Saharan Africa (developing only)?
Give a very brief answer. 0.02. What is the ratio of the Emissions(in percent) in 1963 in Other small states to that in Sub-Saharan Africa (developing only)?
Offer a very short reply. 0.01. What is the ratio of the Emissions(in percent) of 1960 in Small states to that in South Asia?
Keep it short and to the point. 0.01. What is the ratio of the Emissions(in percent) of 1961 in Small states to that in South Asia?
Provide a short and direct response. 0. What is the ratio of the Emissions(in percent) of 1962 in Small states to that in South Asia?
Provide a short and direct response. 0.01. What is the ratio of the Emissions(in percent) in 1963 in Small states to that in South Asia?
Provide a short and direct response. 0.01. What is the ratio of the Emissions(in percent) of 1960 in Small states to that in Sub-Saharan Africa (all income levels)?
Ensure brevity in your answer.  0.01. What is the ratio of the Emissions(in percent) in 1961 in Small states to that in Sub-Saharan Africa (all income levels)?
Offer a terse response. 0. What is the ratio of the Emissions(in percent) of 1962 in Small states to that in Sub-Saharan Africa (all income levels)?
Make the answer very short. 0. What is the ratio of the Emissions(in percent) in 1963 in Small states to that in Sub-Saharan Africa (all income levels)?
Provide a succinct answer. 0.01. What is the ratio of the Emissions(in percent) of 1960 in Small states to that in Sub-Saharan Africa (developing only)?
Give a very brief answer. 0.01. What is the ratio of the Emissions(in percent) of 1961 in Small states to that in Sub-Saharan Africa (developing only)?
Provide a succinct answer. 0. What is the ratio of the Emissions(in percent) in 1962 in Small states to that in Sub-Saharan Africa (developing only)?
Your response must be concise. 0. What is the ratio of the Emissions(in percent) in 1963 in Small states to that in Sub-Saharan Africa (developing only)?
Your answer should be very brief. 0.01. What is the ratio of the Emissions(in percent) of 1960 in South Asia to that in Sub-Saharan Africa (all income levels)?
Offer a very short reply. 0.97. What is the ratio of the Emissions(in percent) in 1961 in South Asia to that in Sub-Saharan Africa (all income levels)?
Offer a terse response. 0.97. What is the ratio of the Emissions(in percent) of 1962 in South Asia to that in Sub-Saharan Africa (all income levels)?
Provide a short and direct response. 0.97. What is the ratio of the Emissions(in percent) in 1963 in South Asia to that in Sub-Saharan Africa (all income levels)?
Your response must be concise. 0.98. What is the ratio of the Emissions(in percent) in 1960 in South Asia to that in Sub-Saharan Africa (developing only)?
Offer a terse response. 0.97. What is the ratio of the Emissions(in percent) in 1961 in South Asia to that in Sub-Saharan Africa (developing only)?
Your answer should be very brief. 0.97. What is the ratio of the Emissions(in percent) of 1962 in South Asia to that in Sub-Saharan Africa (developing only)?
Your response must be concise. 0.97. What is the ratio of the Emissions(in percent) in 1963 in South Asia to that in Sub-Saharan Africa (developing only)?
Provide a short and direct response. 0.98. What is the ratio of the Emissions(in percent) of 1960 in Sub-Saharan Africa (all income levels) to that in Sub-Saharan Africa (developing only)?
Offer a terse response. 1. What is the ratio of the Emissions(in percent) of 1962 in Sub-Saharan Africa (all income levels) to that in Sub-Saharan Africa (developing only)?
Keep it short and to the point. 1. What is the ratio of the Emissions(in percent) of 1963 in Sub-Saharan Africa (all income levels) to that in Sub-Saharan Africa (developing only)?
Keep it short and to the point. 1. What is the difference between the highest and the second highest Emissions(in percent) of 1960?
Offer a very short reply. 0.01. What is the difference between the highest and the second highest Emissions(in percent) of 1961?
Provide a short and direct response. 0.01. What is the difference between the highest and the second highest Emissions(in percent) in 1962?
Keep it short and to the point. 0.01. What is the difference between the highest and the second highest Emissions(in percent) of 1963?
Make the answer very short. 0.02. What is the difference between the highest and the lowest Emissions(in percent) in 1960?
Provide a succinct answer. 77.14. What is the difference between the highest and the lowest Emissions(in percent) in 1961?
Your answer should be compact. 76.94. What is the difference between the highest and the lowest Emissions(in percent) in 1962?
Ensure brevity in your answer.  76.32. What is the difference between the highest and the lowest Emissions(in percent) of 1963?
Offer a terse response. 74.84. 